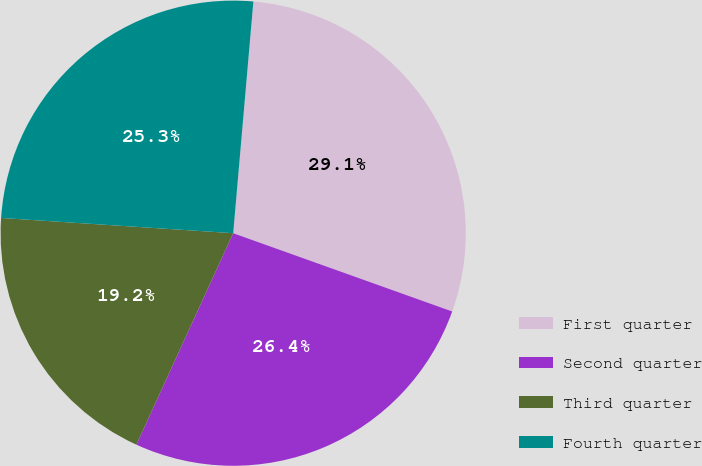<chart> <loc_0><loc_0><loc_500><loc_500><pie_chart><fcel>First quarter<fcel>Second quarter<fcel>Third quarter<fcel>Fourth quarter<nl><fcel>29.08%<fcel>26.37%<fcel>19.21%<fcel>25.34%<nl></chart> 